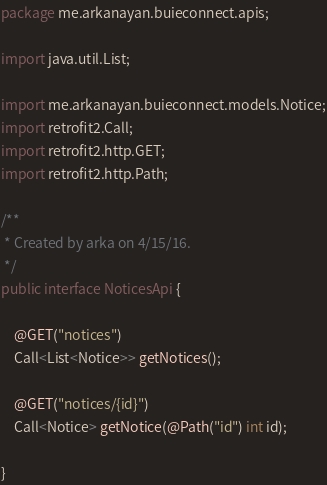Convert code to text. <code><loc_0><loc_0><loc_500><loc_500><_Java_>package me.arkanayan.buieconnect.apis;

import java.util.List;

import me.arkanayan.buieconnect.models.Notice;
import retrofit2.Call;
import retrofit2.http.GET;
import retrofit2.http.Path;

/**
 * Created by arka on 4/15/16.
 */
public interface NoticesApi {

    @GET("notices")
    Call<List<Notice>> getNotices();

    @GET("notices/{id}")
    Call<Notice> getNotice(@Path("id") int id);

}
</code> 